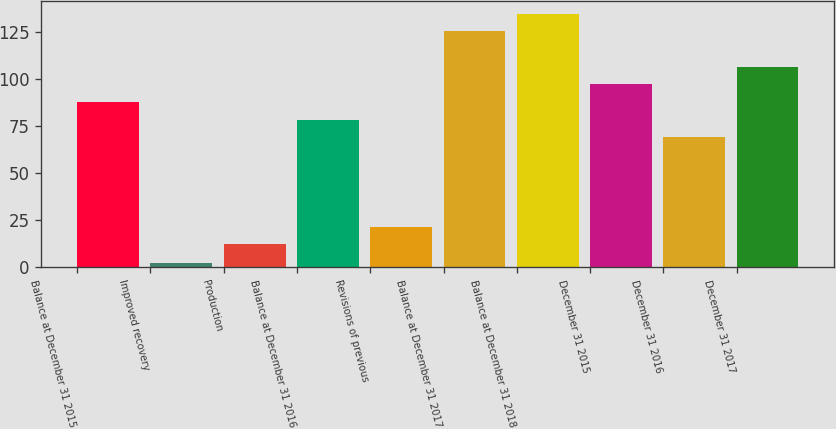Convert chart. <chart><loc_0><loc_0><loc_500><loc_500><bar_chart><fcel>Balance at December 31 2015<fcel>Improved recovery<fcel>Production<fcel>Balance at December 31 2016<fcel>Revisions of previous<fcel>Balance at December 31 2017<fcel>Balance at December 31 2018<fcel>December 31 2015<fcel>December 31 2016<fcel>December 31 2017<nl><fcel>87.8<fcel>2<fcel>12<fcel>78.4<fcel>21.4<fcel>125.4<fcel>134.8<fcel>97.2<fcel>69<fcel>106.6<nl></chart> 